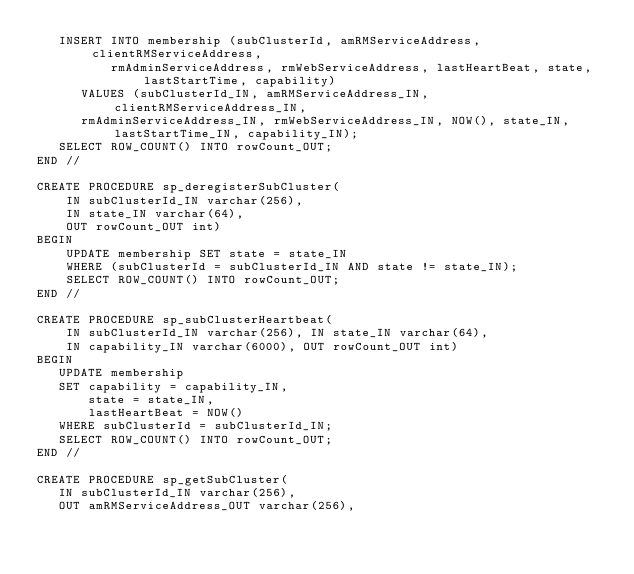<code> <loc_0><loc_0><loc_500><loc_500><_SQL_>   INSERT INTO membership (subClusterId, amRMServiceAddress, clientRMServiceAddress,
          rmAdminServiceAddress, rmWebServiceAddress, lastHeartBeat, state, lastStartTime, capability)
      VALUES (subClusterId_IN, amRMServiceAddress_IN, clientRMServiceAddress_IN,
      rmAdminServiceAddress_IN, rmWebServiceAddress_IN, NOW(), state_IN, lastStartTime_IN, capability_IN);
   SELECT ROW_COUNT() INTO rowCount_OUT;
END //

CREATE PROCEDURE sp_deregisterSubCluster(
    IN subClusterId_IN varchar(256),
    IN state_IN varchar(64),
    OUT rowCount_OUT int)
BEGIN
    UPDATE membership SET state = state_IN
    WHERE (subClusterId = subClusterId_IN AND state != state_IN);
    SELECT ROW_COUNT() INTO rowCount_OUT;
END //

CREATE PROCEDURE sp_subClusterHeartbeat(
    IN subClusterId_IN varchar(256), IN state_IN varchar(64),
    IN capability_IN varchar(6000), OUT rowCount_OUT int)
BEGIN
   UPDATE membership
   SET capability = capability_IN,
       state = state_IN,
       lastHeartBeat = NOW()
   WHERE subClusterId = subClusterId_IN;
   SELECT ROW_COUNT() INTO rowCount_OUT;
END //

CREATE PROCEDURE sp_getSubCluster(
   IN subClusterId_IN varchar(256),
   OUT amRMServiceAddress_OUT varchar(256),</code> 